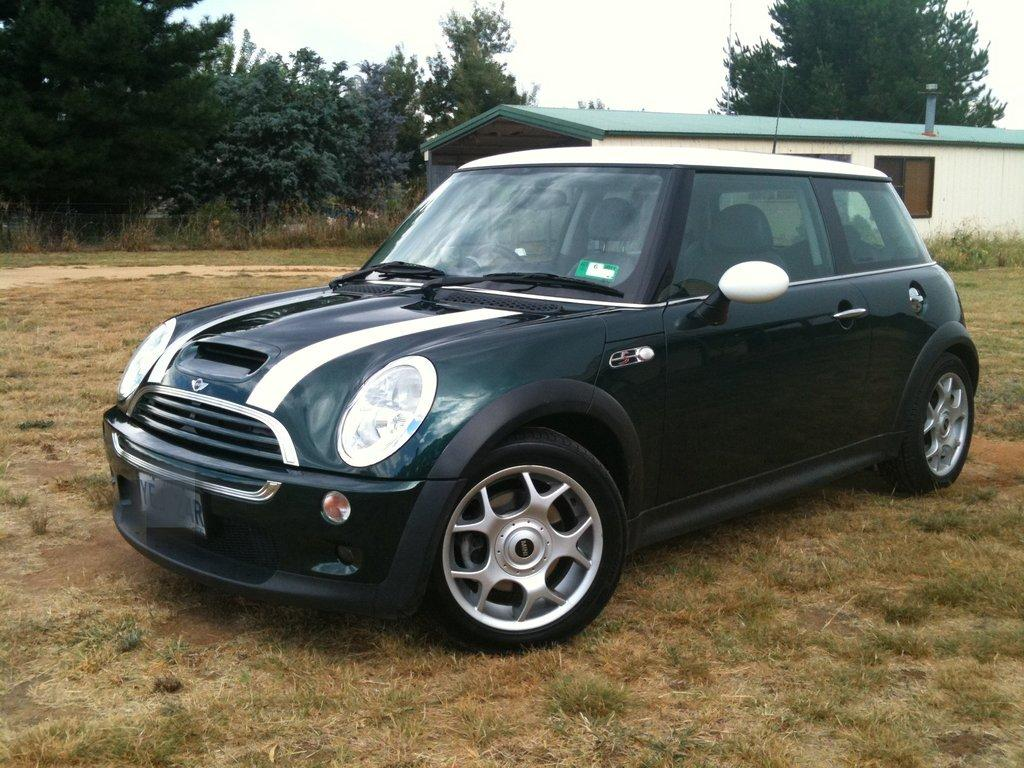What is parked on the ground in the image? There is a car parked on the ground in the image. What type of surface is the car parked on? The ground is covered with grass. What can be seen behind the car in the image? There is a building behind the car. What type of vegetation is present in the image? There are trees in the image. What is the condition of the sky in the image? The sky is clear in the image. What type of bait is being used to catch fish in the image? There is no fishing or bait present in the image; it features a car parked on grass with a building and trees in the background. 